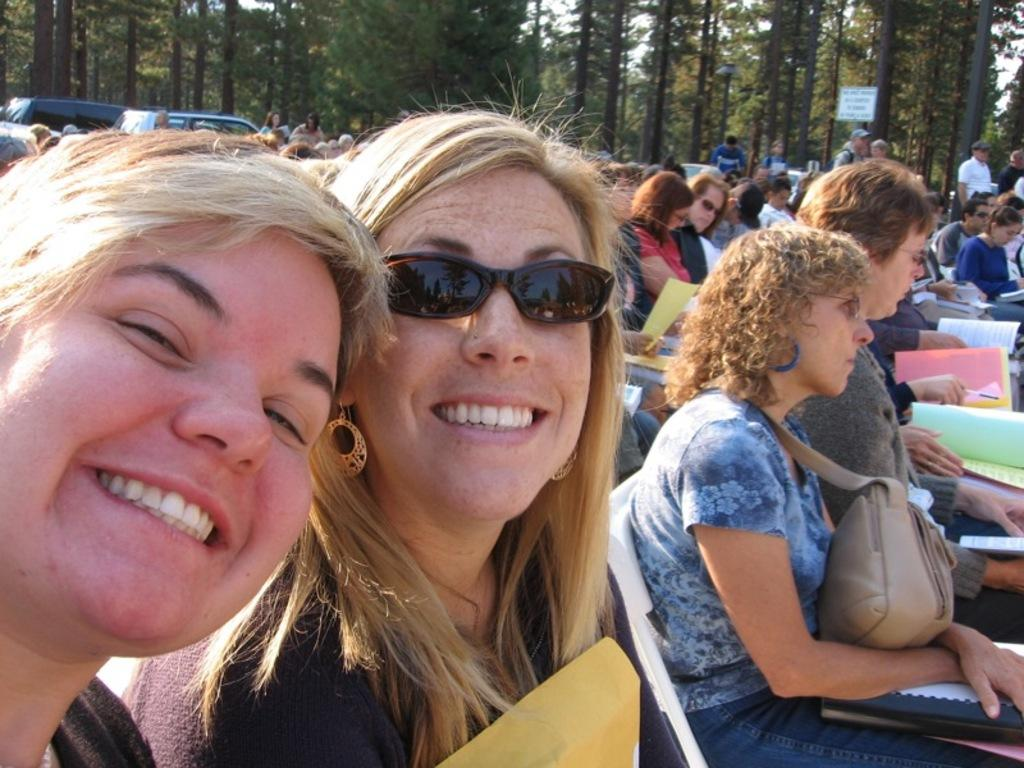How many people are in the image? There are multiple persons in the image. What are the people sitting on in the image? There are chairs in the image, and people are sitting on them. What can be seen at the top of the image? Trees are visible at the top of the image. What items are the people holding in the image? People are holding bags, files, books, and papers in the image. What type of jewel can be seen on the seashore in the image? There is no seashore or jewel present in the image; it features multiple persons sitting on chairs and holding various items. What type of apparel are the people wearing in the image? The provided facts do not mention any specific apparel worn by the people in the image. 